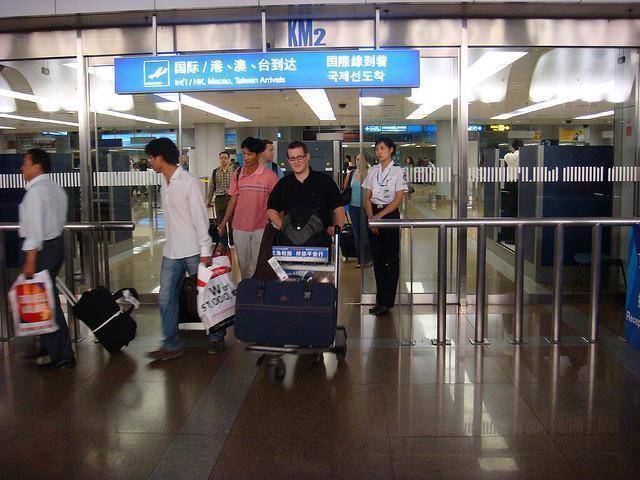What language is the sign in?
Answer the question by selecting the correct answer among the 4 following choices and explain your choice with a short sentence. The answer should be formatted with the following format: `Answer: choice
Rationale: rationale.`
Options: English, chinese, egyptian, french. Answer: chinese.
Rationale: Symbols can be seen on a sign in an airport and asian people are all around. 